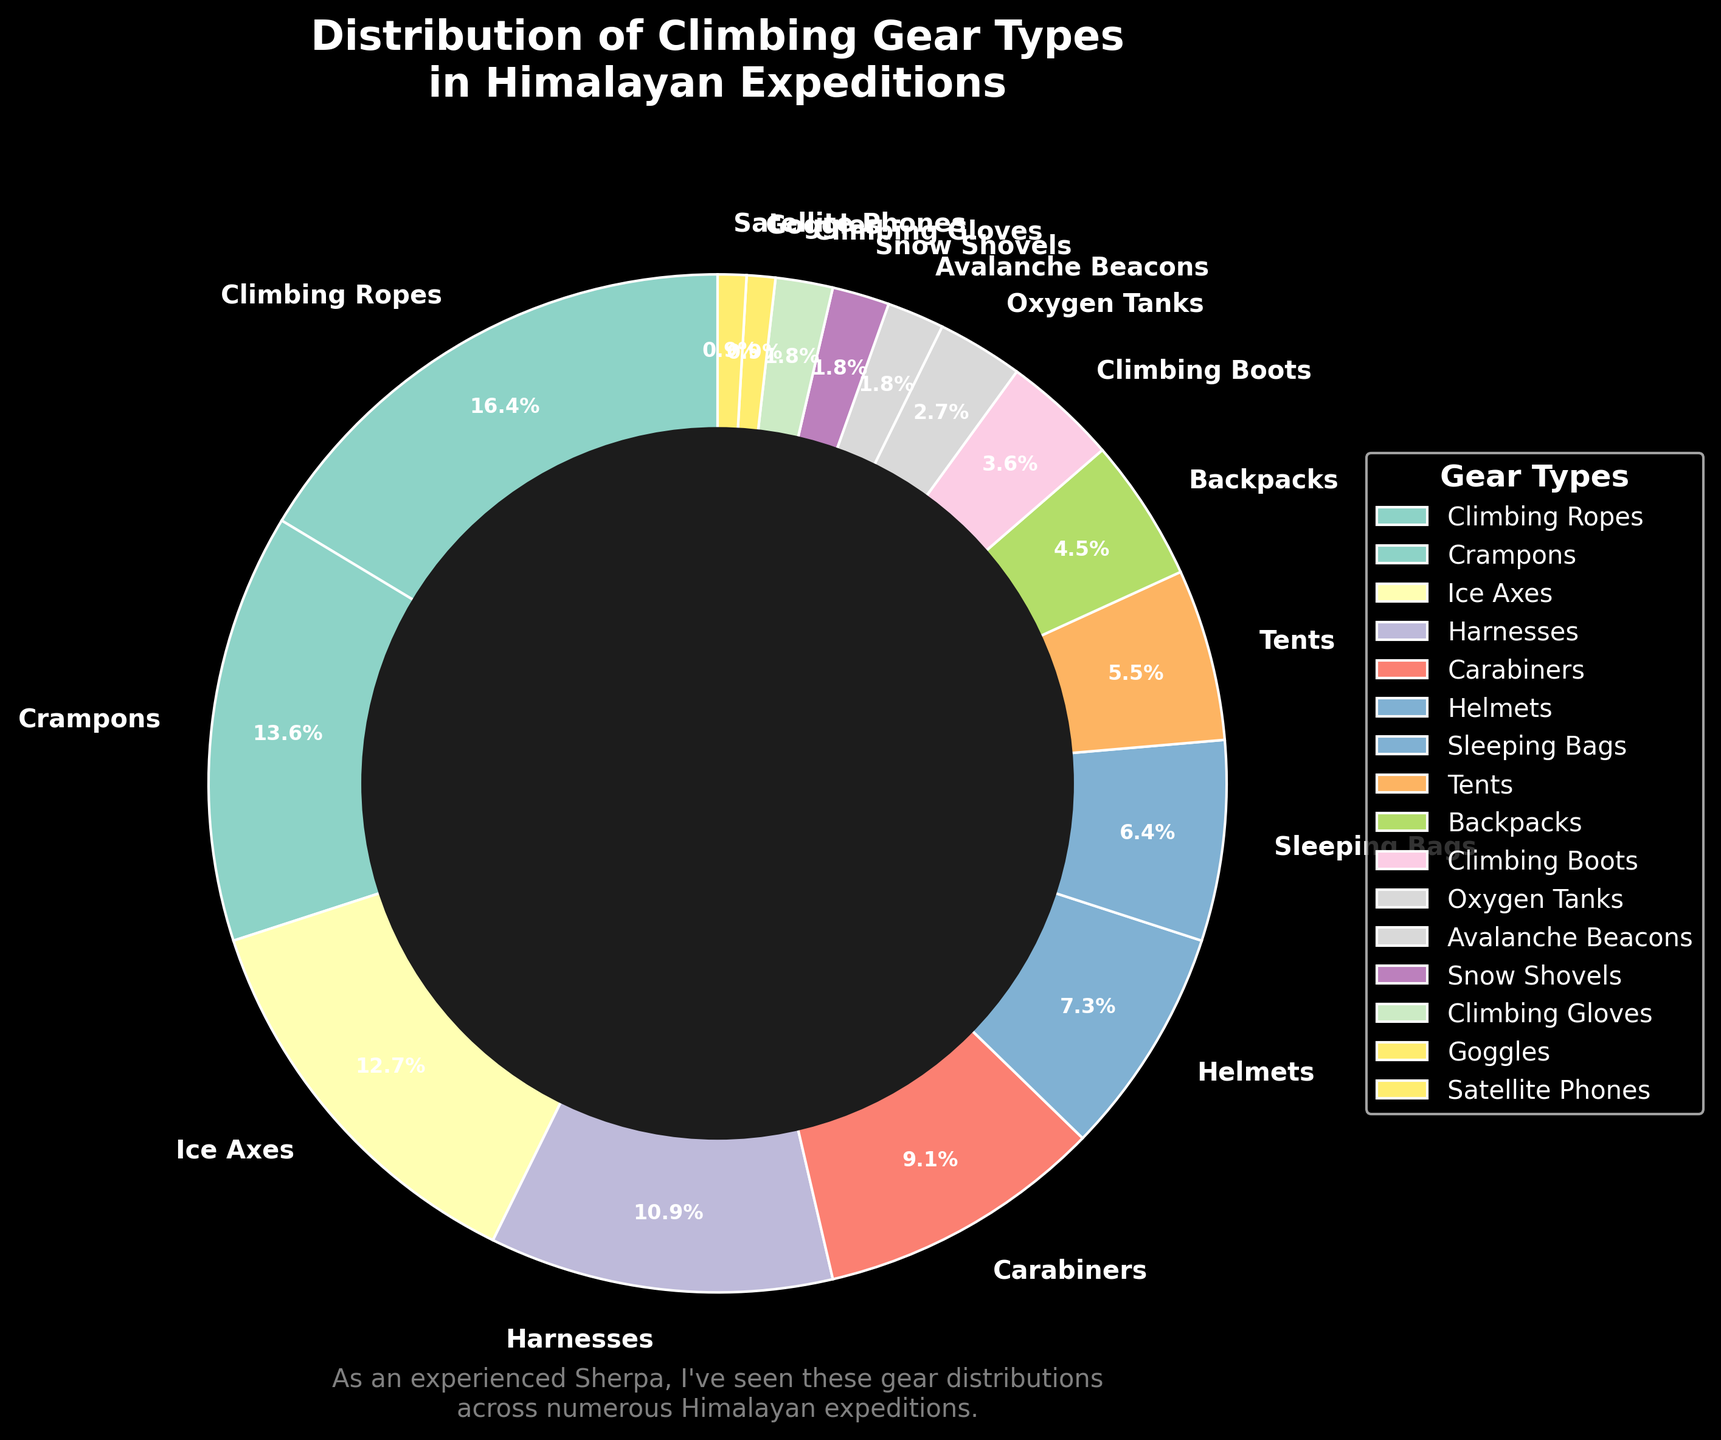what percentage of climbing gear does Climbing Ropes constitute? By referring to the pie chart, we can see that Climbing Ropes make up 18% of the climbing gear distribution.
Answer: 18% Which gear type has the smallest distribution? By examining the chart, we notice that Goggles and Satellite Phones have the smallest distribution at 1% each.
Answer: Goggles and Satellite Phones How many gear types have 5% or less distribution? The gear types with 5% or less distribution are Backpacks (5%), Climbing Boots (4%), Oxygen Tanks (3%), Avalanche Beacons (2%), Snow Shovels (2%), Climbing Gloves (2%), Goggles (1%), and Satellite Phones (1%). Summing these gives us 8 gear types.
Answer: 8 What is the combined percentage of Crampons, Ice Axes, and Helmets? The percentages for Crampons, Ice Axes, and Helmets are 15%, 14%, and 8% respectively. Adding these up: 15 + 14 + 8 = 37%.
Answer: 37% Which gear type has a higher percentage, Carabiners or Harnesses? The pie chart indicates that Harnesses make up 12% while Carabiners constitute 10%. Therefore, Harnesses have a higher percentage.
Answer: Harnesses How does the percentage of Sleeping Bags compare with that of Crampons? Sleeping Bags make up 7% of the gear, while Crampons make up 15%. Thus, Crampons have a higher percentage.
Answer: Crampons What is the total percentage of gear types that are less than 10% each? The gear types under 10% are Carabiners (10%), Helmets (8%), Sleeping Bags (7%), Tents (6%), Backpacks (5%), Climbing Boots (4%), Oxygen Tanks (3%), Avalanche Beacons (2%), Snow Shovels (2%), Climbing Gloves (2%), Goggles (1%), and Satellite Phones (1%). Adding these percentages: 10 + 8 + 7 + 6 + 5 + 4 + 3 + 2 + 2 + 2 + 1 + 1 = 51%.
Answer: 51% Which color represents the Climbing Ropes segment in the pie chart? By looking at the pie chart, we see that the Climbing Ropes section is represented by a particular color, part of the 'Set3' color map. Describing it visually, it appears as a pastel hue within the chart.
Answer: Pastel hue in the pie chart (exact color would depend on rendering) Is the percentage of Ice Axes more than or less than twice the percentage of Climbing Boots? Ice Axes have a percentage of 14% while Climbing Boots have 4%. Calculating twice the percentage of Climbing Boots gives us 4 * 2 = 8%. Therefore, 14% is more than twice 8%.
Answer: More 